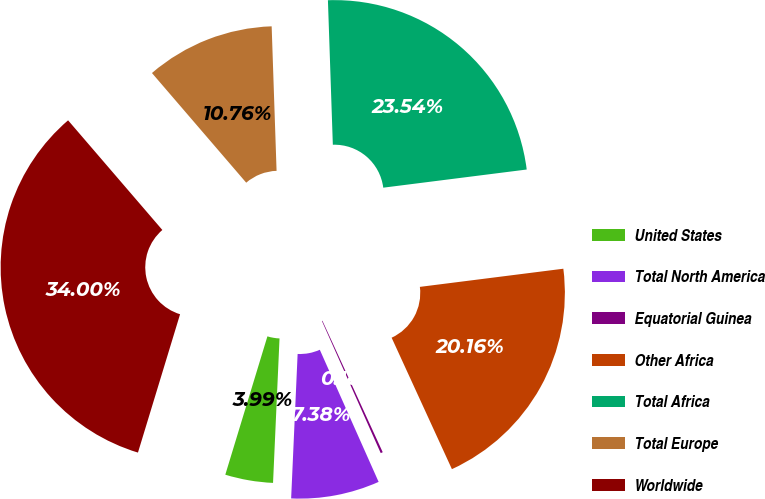Convert chart to OTSL. <chart><loc_0><loc_0><loc_500><loc_500><pie_chart><fcel>United States<fcel>Total North America<fcel>Equatorial Guinea<fcel>Other Africa<fcel>Total Africa<fcel>Total Europe<fcel>Worldwide<nl><fcel>3.99%<fcel>7.38%<fcel>0.18%<fcel>20.16%<fcel>23.54%<fcel>10.76%<fcel>34.0%<nl></chart> 